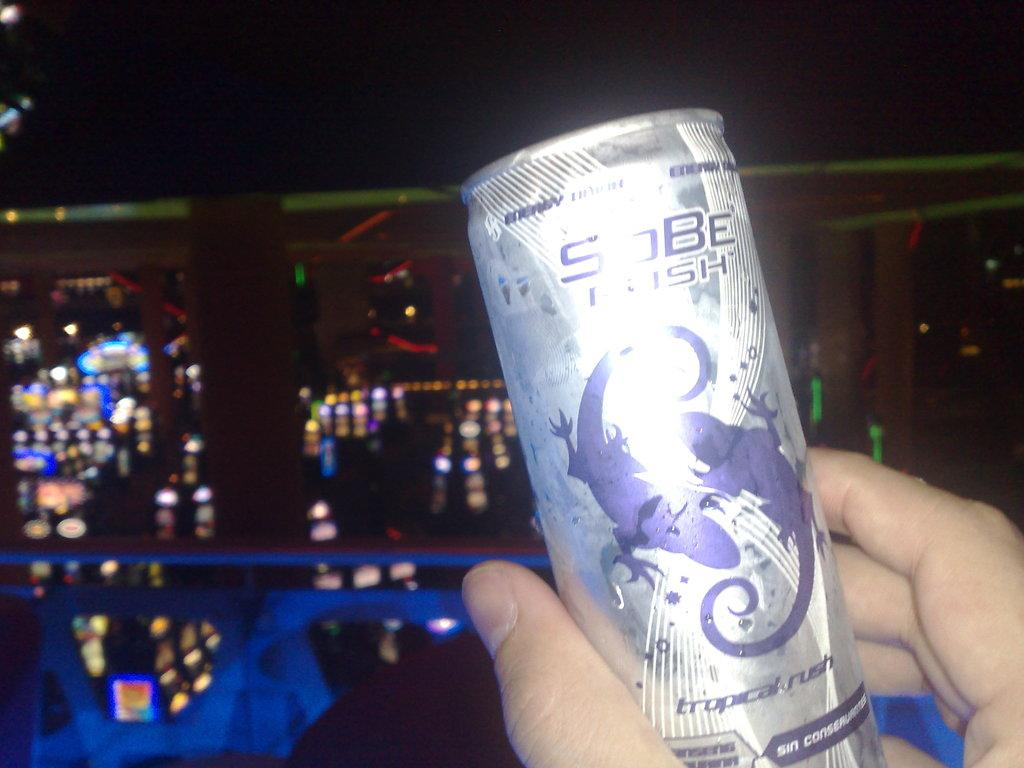<image>
Summarize the visual content of the image. A Sobe energy drink is being held up in someone's hand. 